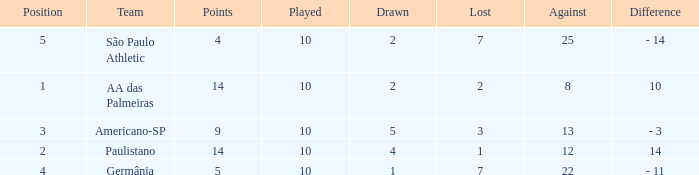What is the Against when the drawn is 5? 13.0. 